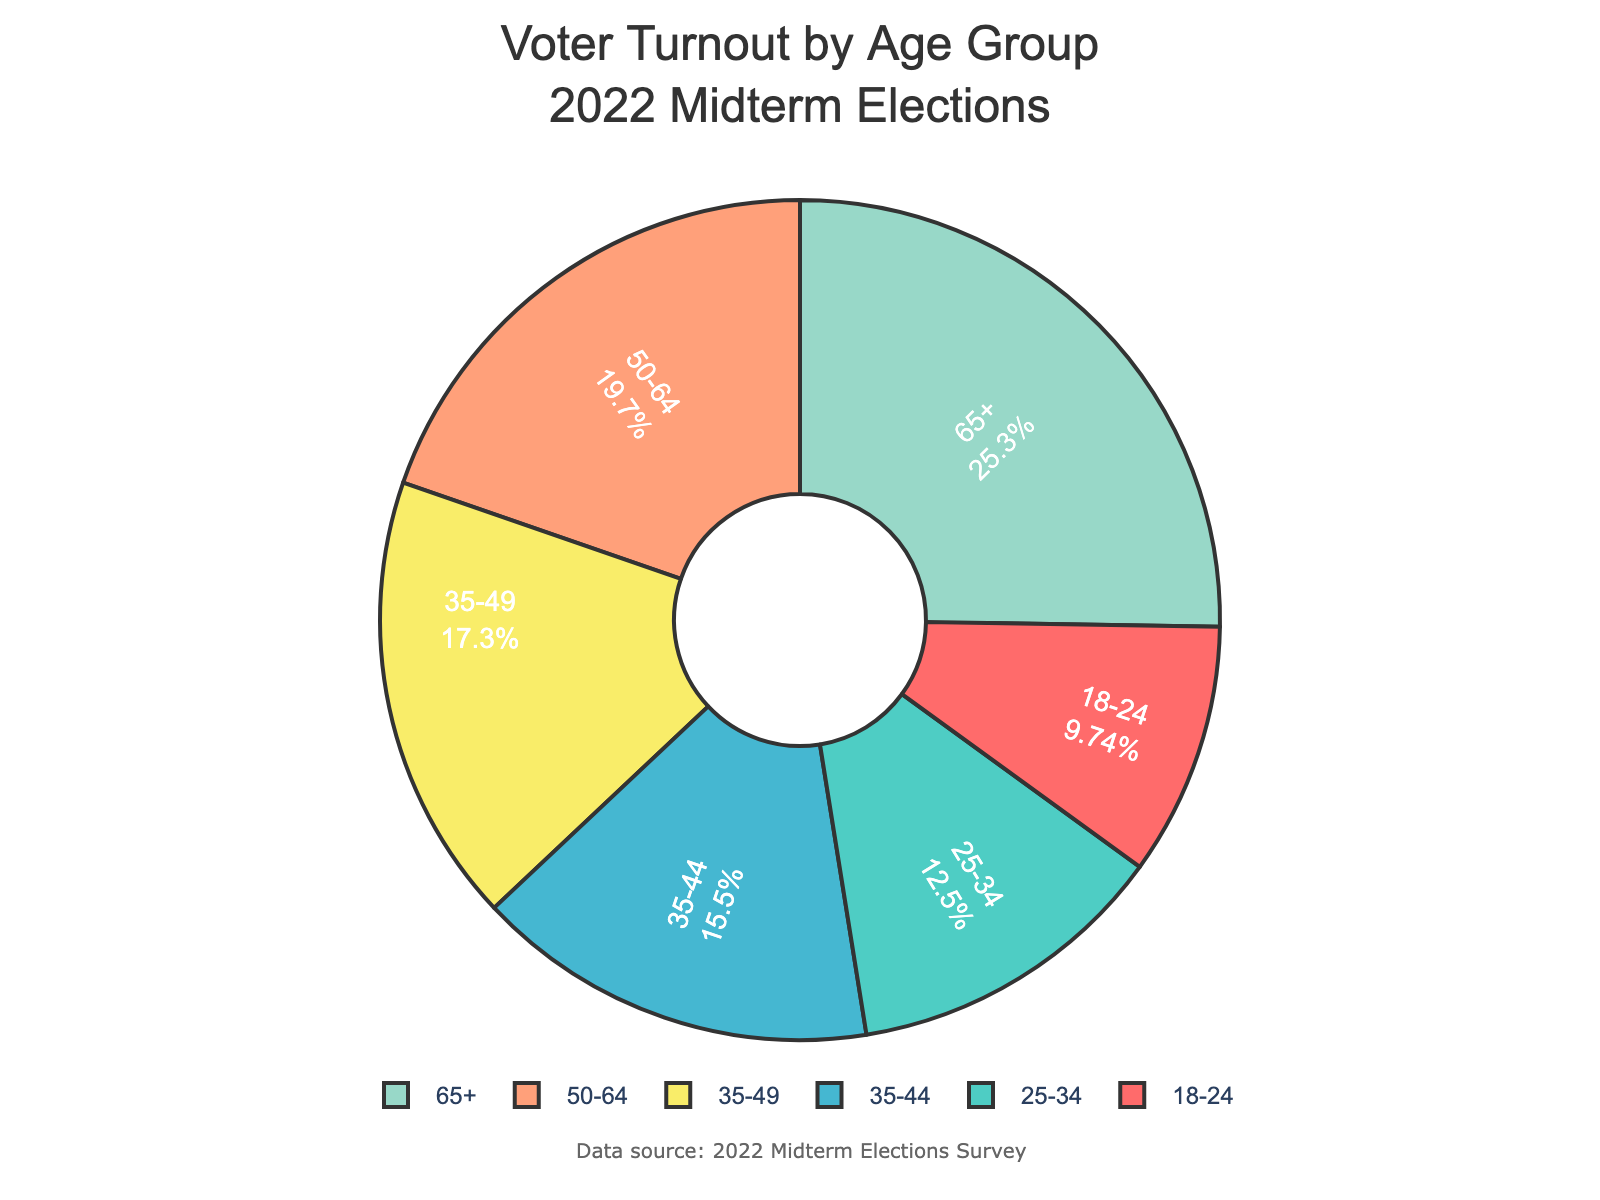Which age group has the highest voter turnout percentage? The figure shows different age groups with their respective voter turnout percentages. The segment with the largest percent value is for age group 65+, which indicates the highest voter turnout.
Answer: 65+ Which age group has the lowest voter turnout percentage? The segment representing the smallest percentage corresponds to the age group 18-24, indicating the lowest voter turnout.
Answer: 18-24 What is the difference in voter turnout percentage between age groups 50-64 and 25-34? According to the figure, the voter turnout for age group 50-64 is 55.6%, and for age group 25-34, it is 35.2%. Subtraction of these two values results in the difference. Hence, 55.6% - 35.2% = 20.4%.
Answer: 20.4% What is the combined voter turnout percentage for the age groups 18-24 and 25-34? According to the figure, the voter turnout for age group 18-24 is 27.5% and for age group 25-34, it is 35.2%. Adding these two percentages together gives the combined voter turnout: 27.5% + 35.2% = 62.7%.
Answer: 62.7% Which two age groups have a combined voter turnout percentage of less than 50%? From the figure, the voter turnout percentages are 27.5% (18-24), 35.2% (25-34), 43.8% (35-44), 48.9% (35-49), 55.6% (50-64), 71.3% (65+). Combining 18-24 (27.5%) and 25-34 (35.2%) gives 62.7%, which is more than 50%. Combining 18-24 (27.5%) and 35-44 (43.8%) gives 71.3%, which is more than 50%. Combining 18-24 (27.5%) and 35-49 (48.9%) gives 76.4%, which is more than 50%. Combining 25-34 (35.2%) and 35-44 (43.8%) gives 79%, which is more than 50%. Combining 25-34 (35.2%) and 35-49 (48.9%) gives 84.1%, which is more than 50%. Upon reviewing combinations, we find no pair sums less than 50%.
Answer: None What is the average voter turnout percentage for the age groups 35-44, 35-49, and 50-64? We first note the voter turnout percentages for these age groups: 43.8%, 48.9%, and 55.6%. Adding these values: 43.8 + 48.9 + 55.6 = 148.3. Then, we divide this sum by the number of groups, which is 3: 148.3 / 3 ≈ 49.43.
Answer: 49.43 Which age groups have a voter turnout percentage within 10% of the age group 35-44? The voter turnout percentage for the age group 35-44 is 43.8%. To find age groups within 10%, we look for percentages between 33.8% and 53.8%. The eligible groups are 25-34 (35.2%), 35-49 (48.9%), and 50-64 (55.6%, not within the range). So, the eligible groups are 25-34 and 35-49.
Answer: 25-34, 35-49 What is the combined voter turnout percentage for all age groups? Summing the voter turnout percentages for all age groups: 27.5 + 35.2 + 43.8 + 55.6 + 71.3 + 48.9 = 282.3%.
Answer: 282.3% What color represents the age group 18-24? On the pie chart, each age group is represented by a different color. The age group 18-24 is represented by the first color in the sequence, which is red.
Answer: Red 